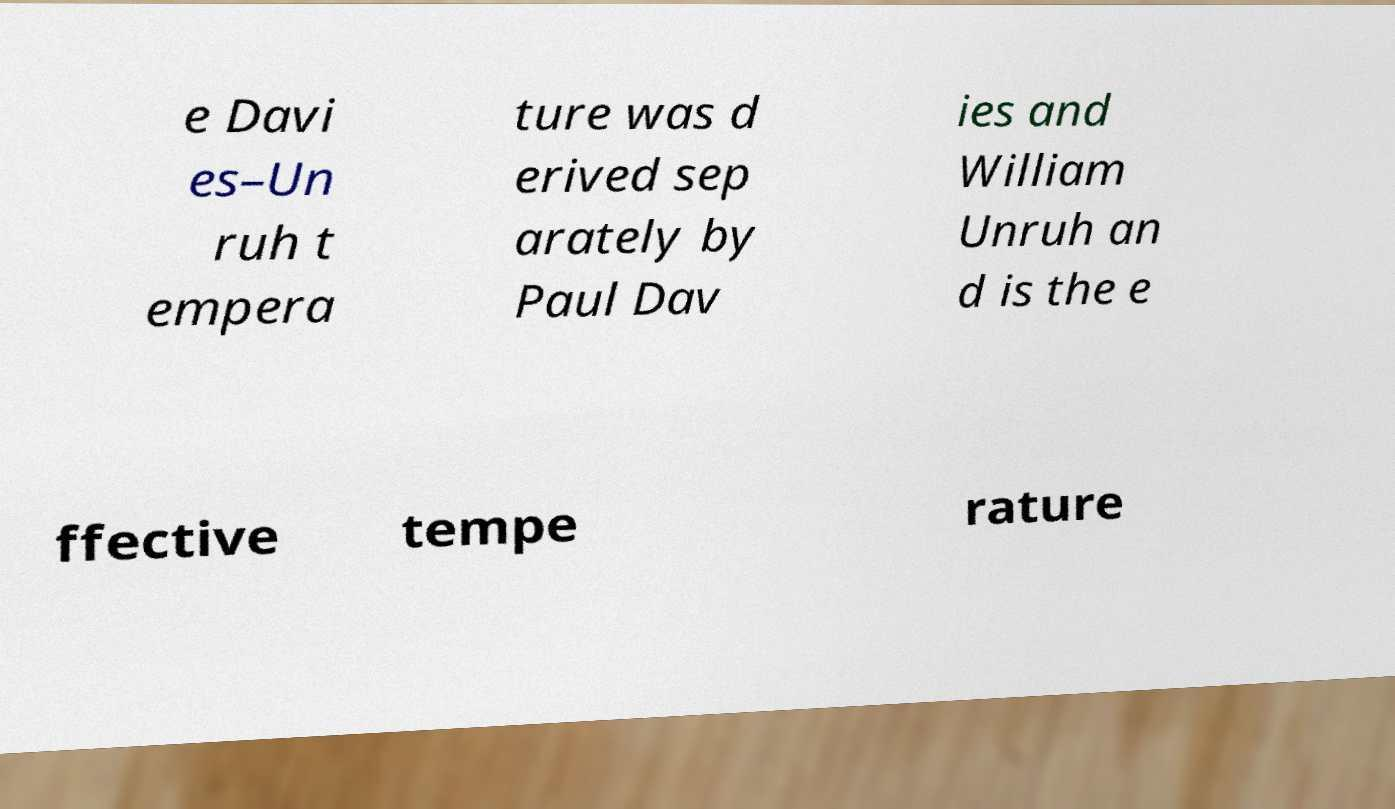Can you read and provide the text displayed in the image?This photo seems to have some interesting text. Can you extract and type it out for me? e Davi es–Un ruh t empera ture was d erived sep arately by Paul Dav ies and William Unruh an d is the e ffective tempe rature 